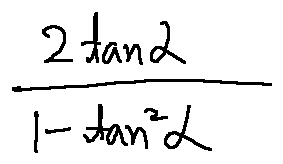Convert formula to latex. <formula><loc_0><loc_0><loc_500><loc_500>\frac { 2 \tan \alpha } { 1 - \tan ^ { 2 } \alpha }</formula> 